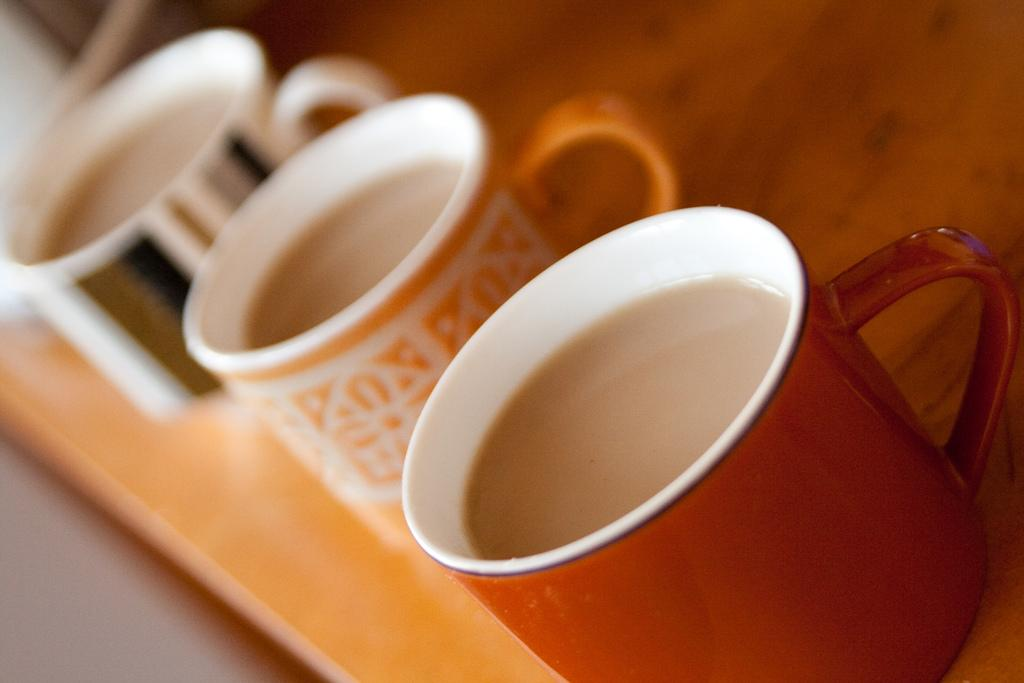What is located in the foreground of the image? There is a tray in the foreground of the image. How many cups are on the tray? There are three cups on the tray. Where are the cups placed? The cups are on a tree. What is inside the cups? There is a drink in the cups. What type of bird can be seen perched on the nerve in the image? There is no bird or nerve present in the image; it features a tray with cups on a tree. 